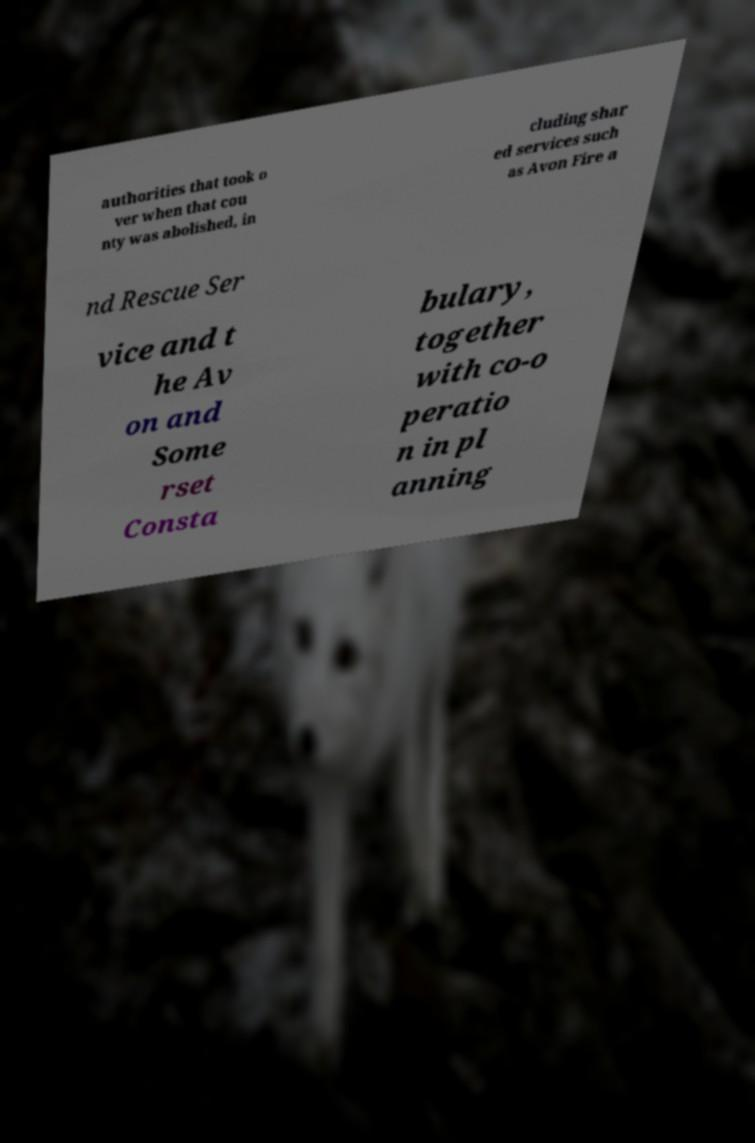For documentation purposes, I need the text within this image transcribed. Could you provide that? authorities that took o ver when that cou nty was abolished, in cluding shar ed services such as Avon Fire a nd Rescue Ser vice and t he Av on and Some rset Consta bulary, together with co-o peratio n in pl anning 